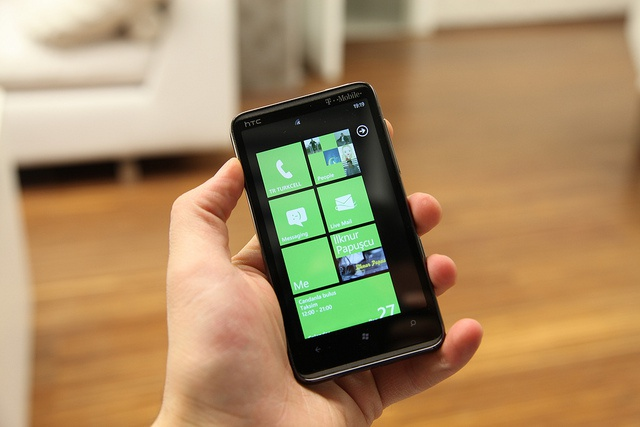Describe the objects in this image and their specific colors. I can see cell phone in ivory, black, and lightgreen tones, couch in ivory, beige, and tan tones, and people in ivory, tan, and gray tones in this image. 